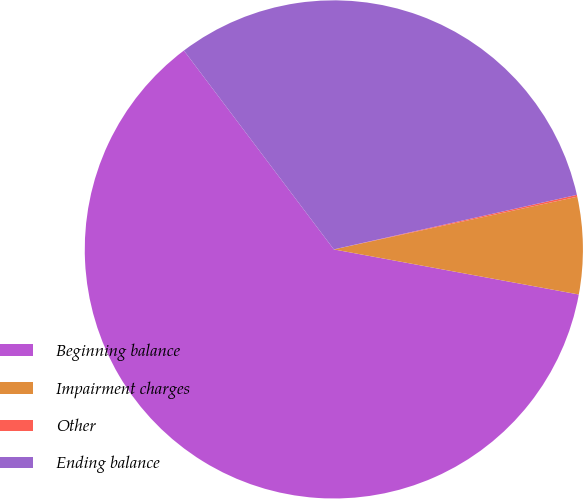<chart> <loc_0><loc_0><loc_500><loc_500><pie_chart><fcel>Beginning balance<fcel>Impairment charges<fcel>Other<fcel>Ending balance<nl><fcel>61.82%<fcel>6.29%<fcel>0.12%<fcel>31.77%<nl></chart> 